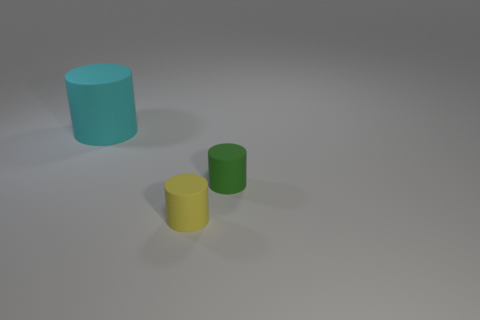Which object appears to be the largest in the image? The object that appears to be the largest in the image is the blue cylinder. 